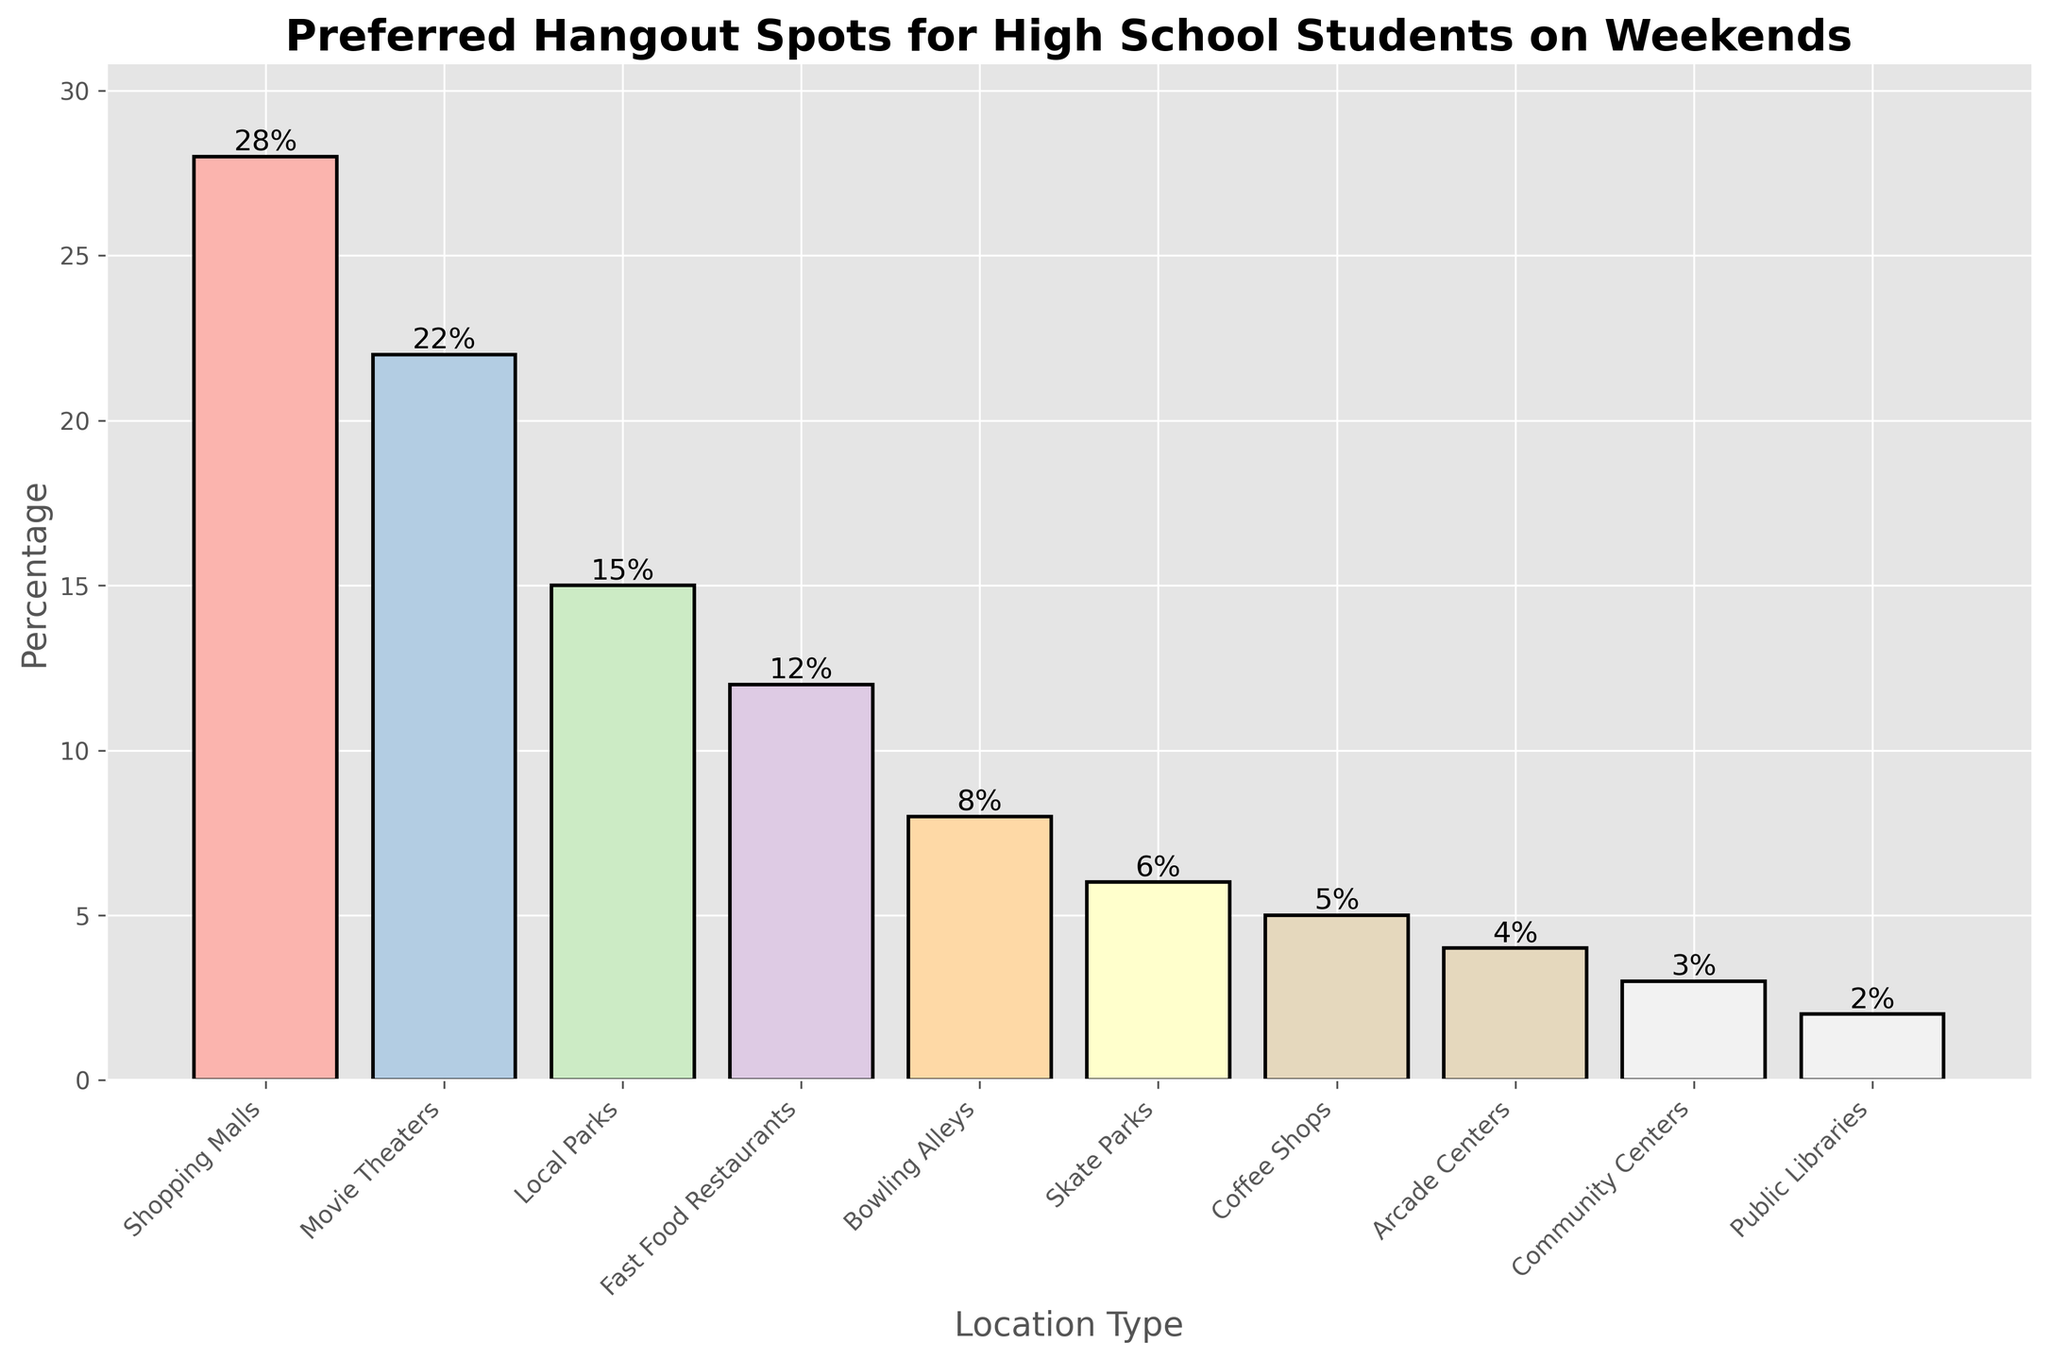Which location type is the most preferred hangout spot for high school students on weekends? The location type with the highest percentage value is the most preferred. In the chart, Shopping Malls have the highest percentage at 28%.
Answer: Shopping Malls Which two location types have the smallest difference in their percentages? To find the smallest difference, subtract the percentage values of all neighboring bars and identify the pair with the smallest positive difference. Fast Food Restaurants (12%) and Bowling Alleys (8%) have a difference of 4%, which is the smallest among all pairs.
Answer: Fast Food Restaurants and Bowling Alleys What is the total percentage of high school students who prefer Local Parks, Skate Parks, and Community Centers combined? Sum the percentages of the three location types: Local Parks (15%) + Skate Parks (6%) + Community Centers (3%) = 24%.
Answer: 24% Which location type has a percentage that is exactly half of any other location type in the chart? Look for a percentage that is exactly half of another percentage shown in the figure. Local Parks (15%) is half of Movie Theaters (30%).
Answer: Local Parks How many locations have a higher percentage than Fast Food Restaurants? Identify the location types with percentages higher than 12% (Fast Food Restaurants). These are Shopping Malls (28%), Movie Theaters (22%), and Local Parks (15%), totaling three locations.
Answer: 3 What is the percentage difference between the most and least preferred hangout spots? Subtract the least percentage from the highest percentage: Shopping Malls (28%) - Public Libraries (2%) = 26%.
Answer: 26% Which location types have percentages below the median percentage value of all given locations? Identify all percentages, sort them and find the median (Middle) value. The median of the 10 percentages {2, 3, 4, 5, 6, 8, 12, 15, 22, 28} is (8+12)/2 = 10. The locations with percentages below 10% are Bowling Alleys (8%), Skate Parks (6%), Coffee Shops (5%), Arcade Centers (4%), Community Centers (3%), and Public Libraries (2%).
Answer: Bowling Alleys, Skate Parks, Coffee Shops, Arcade Centers, Community Centers, and Public Libraries How many location types have percentages that are less than twice the percentage of Coffee Shops? Percentages less than twice Coffee Shops (5%) would be less than 10%. These include Coffee Shops (5%), Arcade Centers (4%), Community Centers (3%), and Public Libraries (2%).
Answer: 4 What percentage of high school students prefer hanging out at Shopping Malls, Movie Theaters, and Fast Food Restaurants combined? Summing these percentages: Shopping Malls (28%) + Movie Theaters (22%) + Fast Food Restaurants (12%) = 62%.
Answer: 62% Which location type on the chart is represented by the second tallest bar? The second tallest bar corresponds to the second highest percentage value. Movie Theaters with 22% is the second tallest bar.
Answer: Movie Theaters 